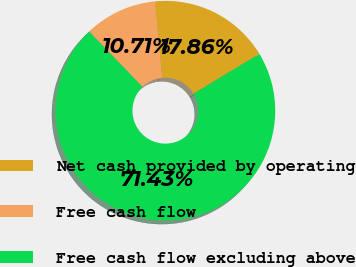<chart> <loc_0><loc_0><loc_500><loc_500><pie_chart><fcel>Net cash provided by operating<fcel>Free cash flow<fcel>Free cash flow excluding above<nl><fcel>17.86%<fcel>10.71%<fcel>71.43%<nl></chart> 